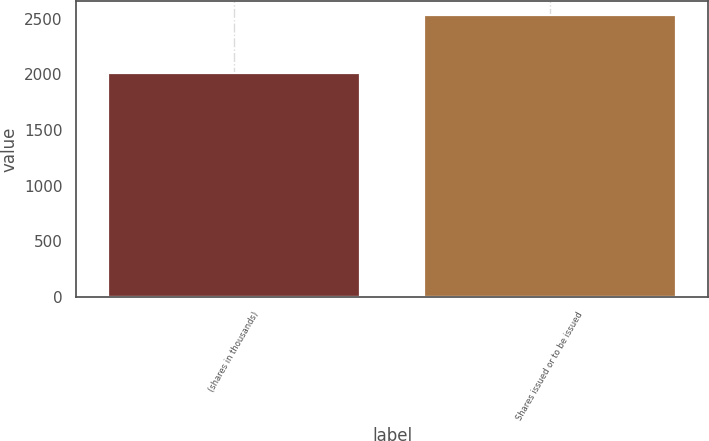<chart> <loc_0><loc_0><loc_500><loc_500><bar_chart><fcel>(shares in thousands)<fcel>Shares issued or to be issued<nl><fcel>2015<fcel>2529<nl></chart> 